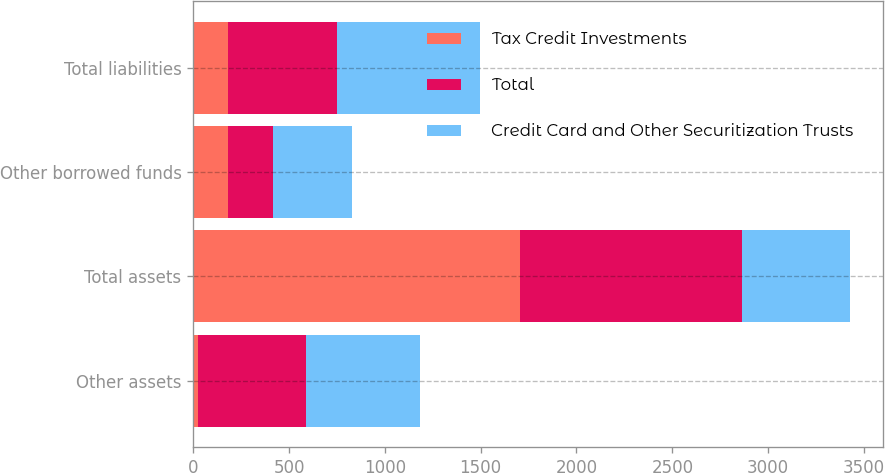<chart> <loc_0><loc_0><loc_500><loc_500><stacked_bar_chart><ecel><fcel>Other assets<fcel>Total assets<fcel>Other borrowed funds<fcel>Total liabilities<nl><fcel>Tax Credit Investments<fcel>25<fcel>1703<fcel>184<fcel>184<nl><fcel>Total<fcel>566<fcel>1160<fcel>230<fcel>565<nl><fcel>Credit Card and Other Securitization Trusts<fcel>591<fcel>565<fcel>414<fcel>749<nl></chart> 